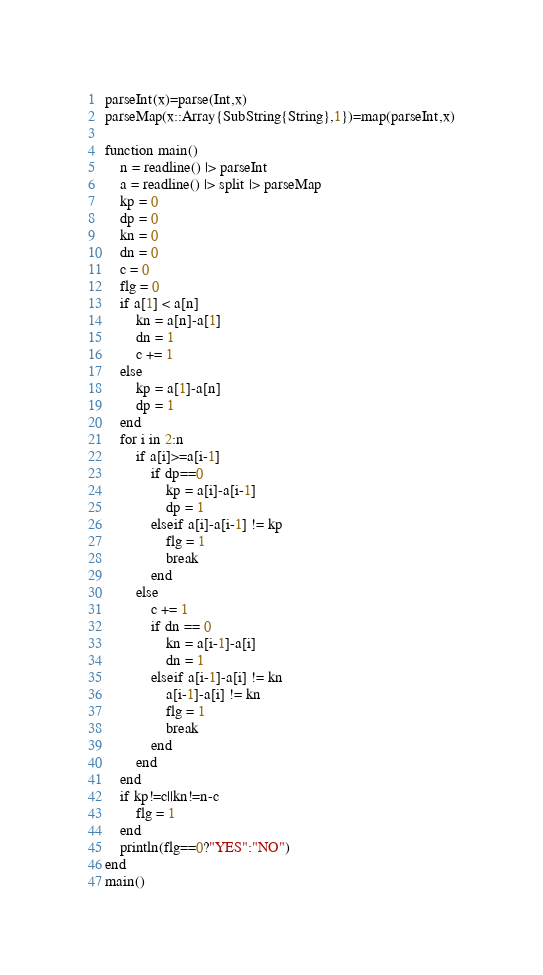<code> <loc_0><loc_0><loc_500><loc_500><_Julia_>parseInt(x)=parse(Int,x)
parseMap(x::Array{SubString{String},1})=map(parseInt,x)

function main()
	n = readline() |> parseInt
	a = readline() |> split |> parseMap
	kp = 0
	dp = 0
	kn = 0
	dn = 0
	c = 0
	flg = 0
	if a[1] < a[n]
		kn = a[n]-a[1]
		dn = 1
		c += 1
	else
		kp = a[1]-a[n]
		dp = 1
	end
	for i in 2:n
		if a[i]>=a[i-1]
			if dp==0
				kp = a[i]-a[i-1]
				dp = 1
			elseif a[i]-a[i-1] != kp
				flg = 1
				break
			end
		else
			c += 1
			if dn == 0
				kn = a[i-1]-a[i]
				dn = 1
			elseif a[i-1]-a[i] != kn
				a[i-1]-a[i] != kn
				flg = 1
				break
			end
		end
	end
	if kp!=c||kn!=n-c
		flg = 1
	end
	println(flg==0?"YES":"NO")
end
main()
</code> 